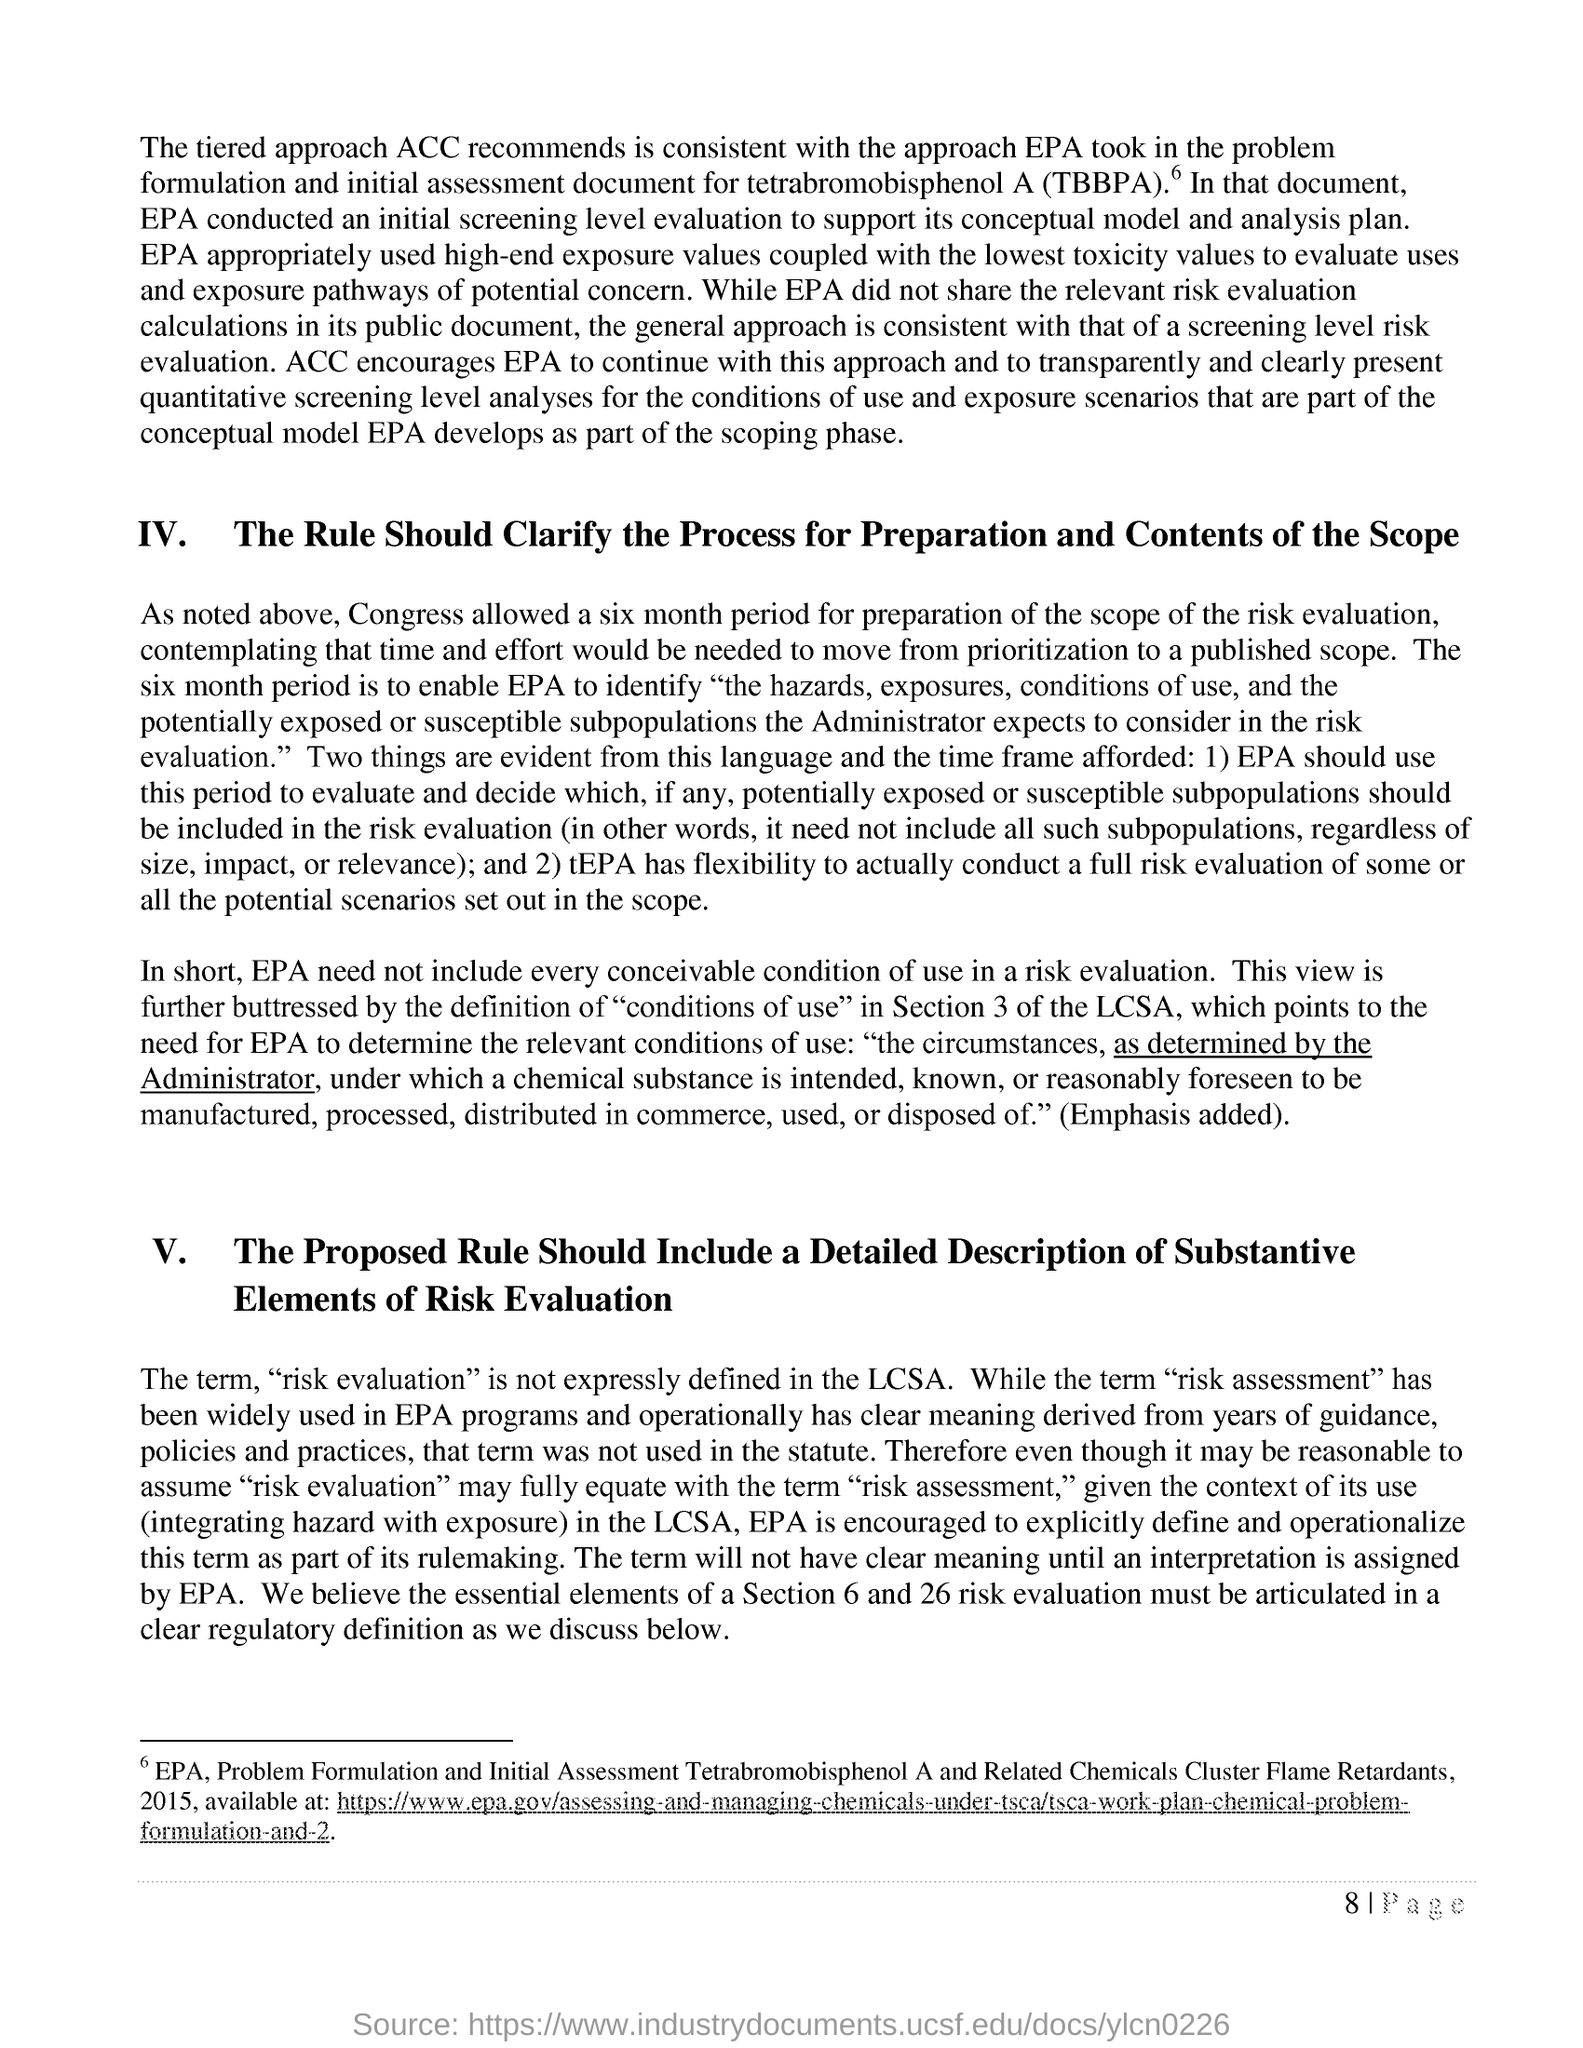Mention a couple of crucial points in this snapshot. TBBPA stands for "tetrabromobisphenol A," which is a chemical compound consisting of a brominated bisphenol. The term 'RISK EVALUATION' was not explicitly defined in the LCSA, as explained in the last paragraph of the document. 